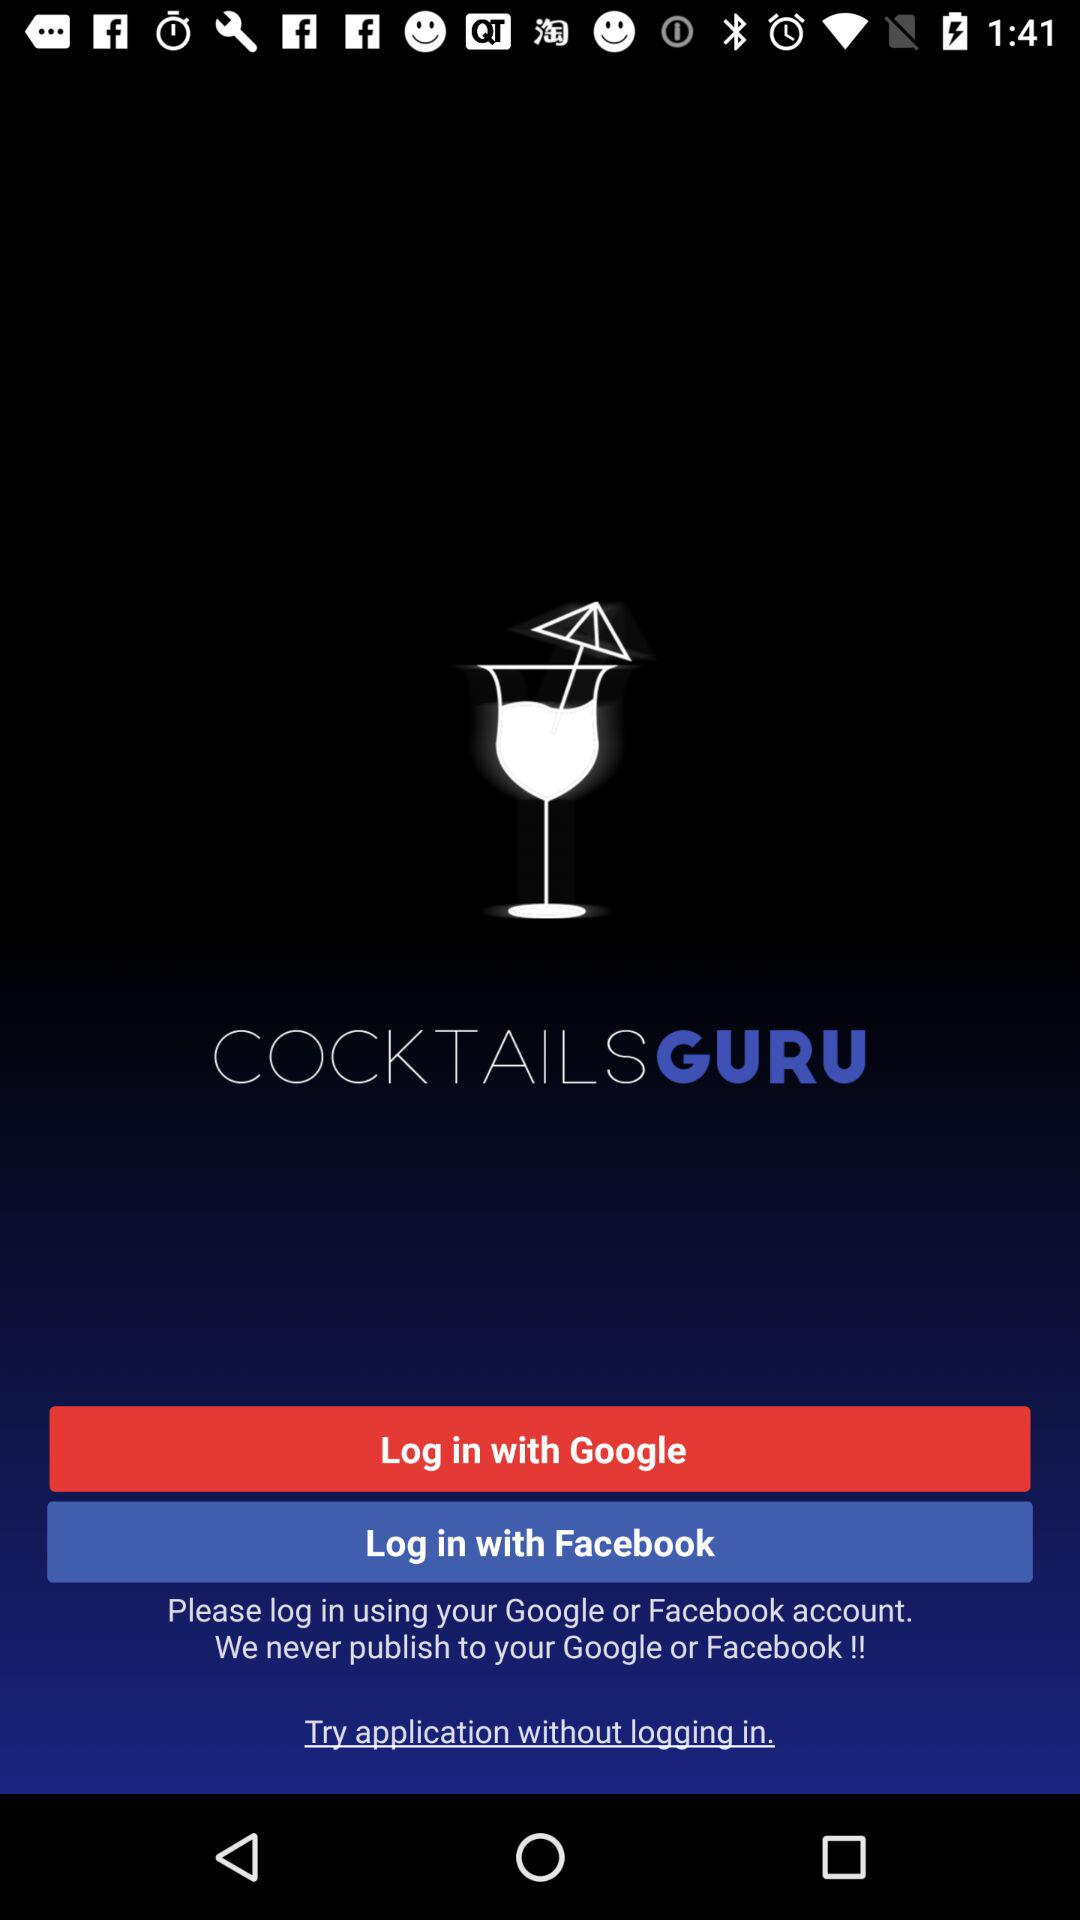How many login options are there on this screen?
Answer the question using a single word or phrase. 2 